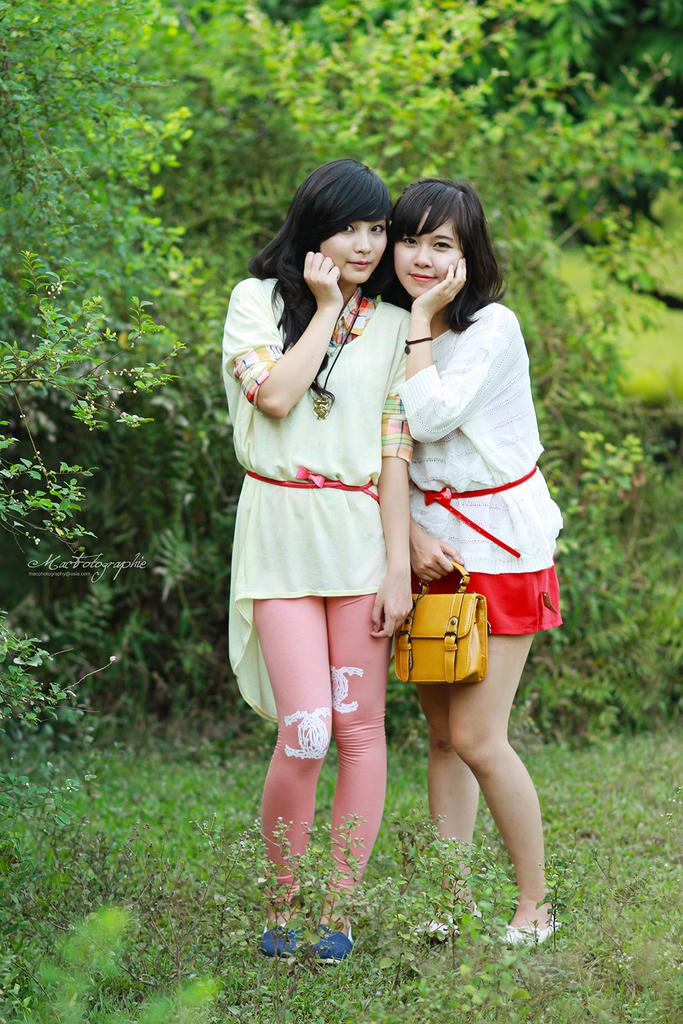How many people are in the picture? There are two girls in the picture. What are the girls doing in the image? Both girls are smiling. Where are the girls standing? The girls are standing on the grass. What can be seen in the background of the image? There are trees in the background of the image. What type of foot treatment is the girl on the left receiving in the image? There is no foot treatment visible in the image; the girls are simply standing on the grass and smiling. 